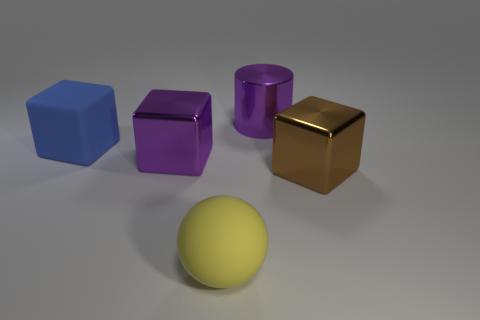Subtract 2 cubes. How many cubes are left? 1 Add 4 purple shiny blocks. How many objects exist? 9 Subtract all brown metallic cubes. How many cubes are left? 2 Subtract all balls. How many objects are left? 4 Subtract all cyan blocks. Subtract all green cylinders. How many blocks are left? 3 Subtract all yellow cylinders. How many blue blocks are left? 1 Subtract all large blue rubber objects. Subtract all big purple shiny objects. How many objects are left? 2 Add 2 shiny things. How many shiny things are left? 5 Add 2 big red blocks. How many big red blocks exist? 2 Subtract all purple blocks. How many blocks are left? 2 